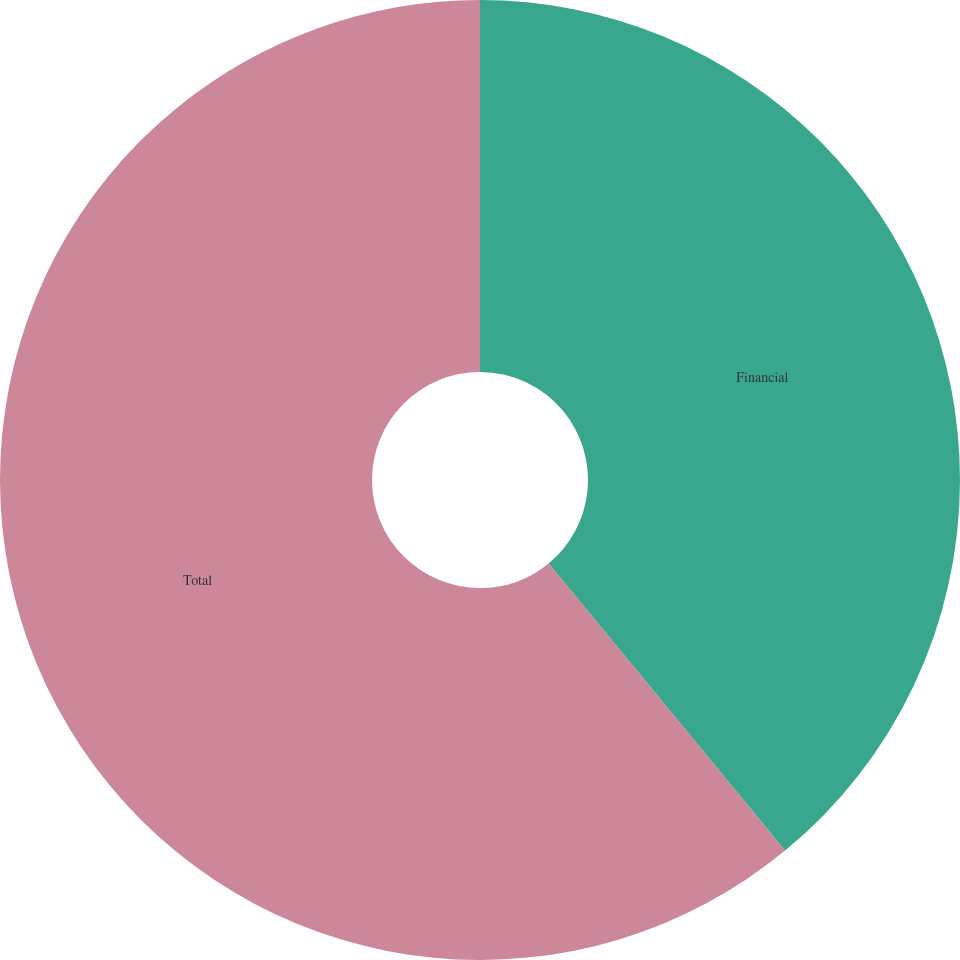Convert chart to OTSL. <chart><loc_0><loc_0><loc_500><loc_500><pie_chart><fcel>Financial<fcel>Total<nl><fcel>39.04%<fcel>60.96%<nl></chart> 